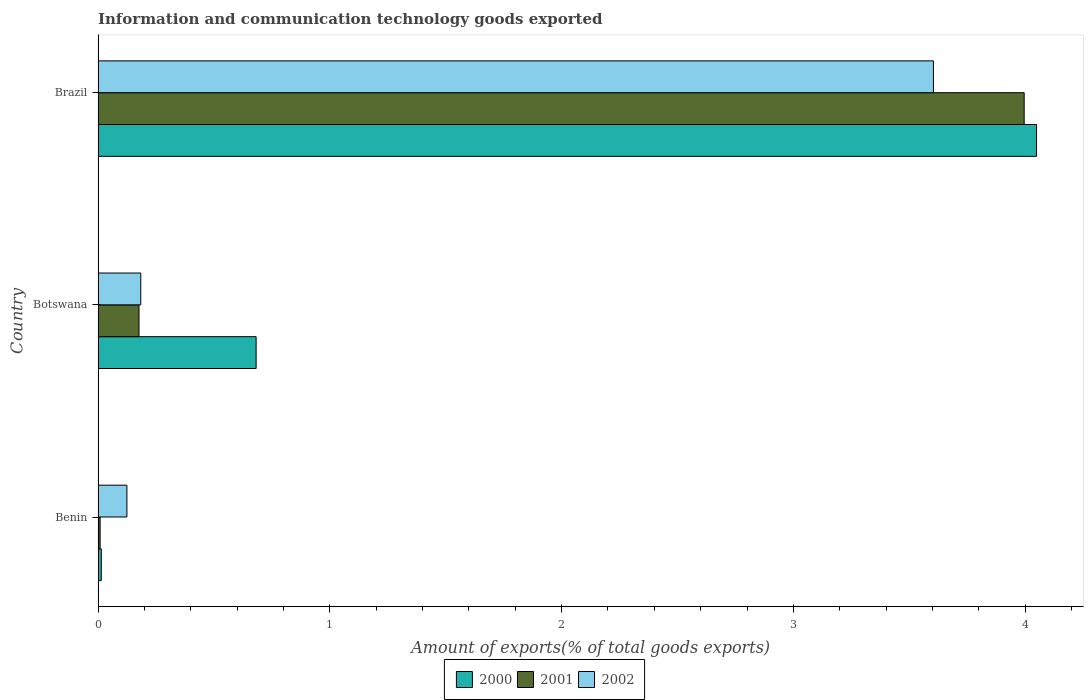How many different coloured bars are there?
Give a very brief answer. 3. Are the number of bars per tick equal to the number of legend labels?
Offer a terse response. Yes. Are the number of bars on each tick of the Y-axis equal?
Your answer should be very brief. Yes. What is the label of the 3rd group of bars from the top?
Provide a short and direct response. Benin. In how many cases, is the number of bars for a given country not equal to the number of legend labels?
Offer a terse response. 0. What is the amount of goods exported in 2001 in Botswana?
Make the answer very short. 0.18. Across all countries, what is the maximum amount of goods exported in 2002?
Ensure brevity in your answer.  3.6. Across all countries, what is the minimum amount of goods exported in 2001?
Provide a short and direct response. 0.01. In which country was the amount of goods exported in 2001 maximum?
Offer a terse response. Brazil. In which country was the amount of goods exported in 2001 minimum?
Provide a succinct answer. Benin. What is the total amount of goods exported in 2001 in the graph?
Offer a terse response. 4.18. What is the difference between the amount of goods exported in 2002 in Botswana and that in Brazil?
Your response must be concise. -3.42. What is the difference between the amount of goods exported in 2000 in Benin and the amount of goods exported in 2001 in Brazil?
Offer a very short reply. -3.98. What is the average amount of goods exported in 2001 per country?
Your answer should be compact. 1.39. What is the difference between the amount of goods exported in 2001 and amount of goods exported in 2000 in Benin?
Your response must be concise. -0.01. What is the ratio of the amount of goods exported in 2000 in Benin to that in Brazil?
Offer a terse response. 0. Is the amount of goods exported in 2002 in Benin less than that in Botswana?
Your answer should be compact. Yes. What is the difference between the highest and the second highest amount of goods exported in 2001?
Your answer should be very brief. 3.82. What is the difference between the highest and the lowest amount of goods exported in 2000?
Make the answer very short. 4.04. Is the sum of the amount of goods exported in 2000 in Benin and Botswana greater than the maximum amount of goods exported in 2002 across all countries?
Give a very brief answer. No. Are the values on the major ticks of X-axis written in scientific E-notation?
Provide a short and direct response. No. Does the graph contain any zero values?
Make the answer very short. No. Does the graph contain grids?
Make the answer very short. No. Where does the legend appear in the graph?
Ensure brevity in your answer.  Bottom center. How many legend labels are there?
Provide a short and direct response. 3. What is the title of the graph?
Give a very brief answer. Information and communication technology goods exported. Does "1968" appear as one of the legend labels in the graph?
Ensure brevity in your answer.  No. What is the label or title of the X-axis?
Keep it short and to the point. Amount of exports(% of total goods exports). What is the Amount of exports(% of total goods exports) of 2000 in Benin?
Give a very brief answer. 0.01. What is the Amount of exports(% of total goods exports) of 2001 in Benin?
Offer a very short reply. 0.01. What is the Amount of exports(% of total goods exports) of 2002 in Benin?
Give a very brief answer. 0.12. What is the Amount of exports(% of total goods exports) in 2000 in Botswana?
Ensure brevity in your answer.  0.68. What is the Amount of exports(% of total goods exports) of 2001 in Botswana?
Make the answer very short. 0.18. What is the Amount of exports(% of total goods exports) in 2002 in Botswana?
Your answer should be compact. 0.18. What is the Amount of exports(% of total goods exports) in 2000 in Brazil?
Provide a short and direct response. 4.05. What is the Amount of exports(% of total goods exports) of 2001 in Brazil?
Your response must be concise. 4. What is the Amount of exports(% of total goods exports) of 2002 in Brazil?
Your answer should be compact. 3.6. Across all countries, what is the maximum Amount of exports(% of total goods exports) in 2000?
Keep it short and to the point. 4.05. Across all countries, what is the maximum Amount of exports(% of total goods exports) of 2001?
Keep it short and to the point. 4. Across all countries, what is the maximum Amount of exports(% of total goods exports) of 2002?
Provide a succinct answer. 3.6. Across all countries, what is the minimum Amount of exports(% of total goods exports) of 2000?
Ensure brevity in your answer.  0.01. Across all countries, what is the minimum Amount of exports(% of total goods exports) of 2001?
Provide a succinct answer. 0.01. Across all countries, what is the minimum Amount of exports(% of total goods exports) in 2002?
Keep it short and to the point. 0.12. What is the total Amount of exports(% of total goods exports) of 2000 in the graph?
Make the answer very short. 4.74. What is the total Amount of exports(% of total goods exports) in 2001 in the graph?
Ensure brevity in your answer.  4.18. What is the total Amount of exports(% of total goods exports) in 2002 in the graph?
Give a very brief answer. 3.91. What is the difference between the Amount of exports(% of total goods exports) in 2000 in Benin and that in Botswana?
Provide a short and direct response. -0.67. What is the difference between the Amount of exports(% of total goods exports) in 2001 in Benin and that in Botswana?
Offer a very short reply. -0.17. What is the difference between the Amount of exports(% of total goods exports) of 2002 in Benin and that in Botswana?
Offer a terse response. -0.06. What is the difference between the Amount of exports(% of total goods exports) of 2000 in Benin and that in Brazil?
Keep it short and to the point. -4.04. What is the difference between the Amount of exports(% of total goods exports) of 2001 in Benin and that in Brazil?
Your answer should be compact. -3.99. What is the difference between the Amount of exports(% of total goods exports) of 2002 in Benin and that in Brazil?
Make the answer very short. -3.48. What is the difference between the Amount of exports(% of total goods exports) of 2000 in Botswana and that in Brazil?
Your answer should be very brief. -3.37. What is the difference between the Amount of exports(% of total goods exports) of 2001 in Botswana and that in Brazil?
Provide a succinct answer. -3.82. What is the difference between the Amount of exports(% of total goods exports) in 2002 in Botswana and that in Brazil?
Ensure brevity in your answer.  -3.42. What is the difference between the Amount of exports(% of total goods exports) of 2000 in Benin and the Amount of exports(% of total goods exports) of 2001 in Botswana?
Keep it short and to the point. -0.16. What is the difference between the Amount of exports(% of total goods exports) in 2000 in Benin and the Amount of exports(% of total goods exports) in 2002 in Botswana?
Provide a short and direct response. -0.17. What is the difference between the Amount of exports(% of total goods exports) of 2001 in Benin and the Amount of exports(% of total goods exports) of 2002 in Botswana?
Ensure brevity in your answer.  -0.18. What is the difference between the Amount of exports(% of total goods exports) of 2000 in Benin and the Amount of exports(% of total goods exports) of 2001 in Brazil?
Your answer should be very brief. -3.98. What is the difference between the Amount of exports(% of total goods exports) in 2000 in Benin and the Amount of exports(% of total goods exports) in 2002 in Brazil?
Provide a succinct answer. -3.59. What is the difference between the Amount of exports(% of total goods exports) in 2001 in Benin and the Amount of exports(% of total goods exports) in 2002 in Brazil?
Keep it short and to the point. -3.6. What is the difference between the Amount of exports(% of total goods exports) of 2000 in Botswana and the Amount of exports(% of total goods exports) of 2001 in Brazil?
Provide a short and direct response. -3.31. What is the difference between the Amount of exports(% of total goods exports) of 2000 in Botswana and the Amount of exports(% of total goods exports) of 2002 in Brazil?
Provide a succinct answer. -2.92. What is the difference between the Amount of exports(% of total goods exports) in 2001 in Botswana and the Amount of exports(% of total goods exports) in 2002 in Brazil?
Provide a short and direct response. -3.43. What is the average Amount of exports(% of total goods exports) of 2000 per country?
Your answer should be compact. 1.58. What is the average Amount of exports(% of total goods exports) of 2001 per country?
Your answer should be compact. 1.39. What is the average Amount of exports(% of total goods exports) of 2002 per country?
Your answer should be very brief. 1.3. What is the difference between the Amount of exports(% of total goods exports) in 2000 and Amount of exports(% of total goods exports) in 2001 in Benin?
Offer a terse response. 0.01. What is the difference between the Amount of exports(% of total goods exports) of 2000 and Amount of exports(% of total goods exports) of 2002 in Benin?
Your answer should be very brief. -0.11. What is the difference between the Amount of exports(% of total goods exports) of 2001 and Amount of exports(% of total goods exports) of 2002 in Benin?
Keep it short and to the point. -0.12. What is the difference between the Amount of exports(% of total goods exports) in 2000 and Amount of exports(% of total goods exports) in 2001 in Botswana?
Give a very brief answer. 0.51. What is the difference between the Amount of exports(% of total goods exports) of 2000 and Amount of exports(% of total goods exports) of 2002 in Botswana?
Make the answer very short. 0.5. What is the difference between the Amount of exports(% of total goods exports) of 2001 and Amount of exports(% of total goods exports) of 2002 in Botswana?
Your answer should be very brief. -0.01. What is the difference between the Amount of exports(% of total goods exports) of 2000 and Amount of exports(% of total goods exports) of 2001 in Brazil?
Your answer should be very brief. 0.05. What is the difference between the Amount of exports(% of total goods exports) in 2000 and Amount of exports(% of total goods exports) in 2002 in Brazil?
Ensure brevity in your answer.  0.45. What is the difference between the Amount of exports(% of total goods exports) of 2001 and Amount of exports(% of total goods exports) of 2002 in Brazil?
Provide a short and direct response. 0.39. What is the ratio of the Amount of exports(% of total goods exports) of 2000 in Benin to that in Botswana?
Offer a very short reply. 0.02. What is the ratio of the Amount of exports(% of total goods exports) in 2001 in Benin to that in Botswana?
Keep it short and to the point. 0.05. What is the ratio of the Amount of exports(% of total goods exports) in 2002 in Benin to that in Botswana?
Your answer should be compact. 0.68. What is the ratio of the Amount of exports(% of total goods exports) in 2000 in Benin to that in Brazil?
Give a very brief answer. 0. What is the ratio of the Amount of exports(% of total goods exports) in 2001 in Benin to that in Brazil?
Keep it short and to the point. 0. What is the ratio of the Amount of exports(% of total goods exports) of 2002 in Benin to that in Brazil?
Your response must be concise. 0.03. What is the ratio of the Amount of exports(% of total goods exports) in 2000 in Botswana to that in Brazil?
Your answer should be compact. 0.17. What is the ratio of the Amount of exports(% of total goods exports) of 2001 in Botswana to that in Brazil?
Offer a terse response. 0.04. What is the ratio of the Amount of exports(% of total goods exports) in 2002 in Botswana to that in Brazil?
Ensure brevity in your answer.  0.05. What is the difference between the highest and the second highest Amount of exports(% of total goods exports) of 2000?
Offer a terse response. 3.37. What is the difference between the highest and the second highest Amount of exports(% of total goods exports) of 2001?
Your response must be concise. 3.82. What is the difference between the highest and the second highest Amount of exports(% of total goods exports) in 2002?
Your answer should be very brief. 3.42. What is the difference between the highest and the lowest Amount of exports(% of total goods exports) in 2000?
Ensure brevity in your answer.  4.04. What is the difference between the highest and the lowest Amount of exports(% of total goods exports) of 2001?
Your answer should be compact. 3.99. What is the difference between the highest and the lowest Amount of exports(% of total goods exports) in 2002?
Your answer should be compact. 3.48. 